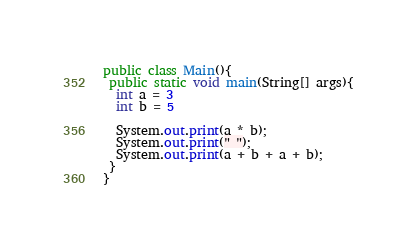Convert code to text. <code><loc_0><loc_0><loc_500><loc_500><_Java_>public class Main(){
 public static void main(String[] args){
  int a = 3
  int b = 5

  System.out.print(a * b);
  System.out.print(" ");
  System.out.print(a + b + a + b);
 }
}
</code> 